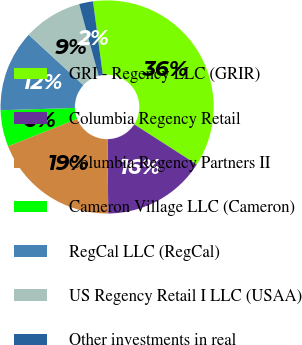Convert chart. <chart><loc_0><loc_0><loc_500><loc_500><pie_chart><fcel>GRI - Regency LLC (GRIR)<fcel>Columbia Regency Retail<fcel>Columbia Regency Partners II<fcel>Cameron Village LLC (Cameron)<fcel>RegCal LLC (RegCal)<fcel>US Regency Retail I LLC (USAA)<fcel>Other investments in real<nl><fcel>36.2%<fcel>15.75%<fcel>19.16%<fcel>5.52%<fcel>12.34%<fcel>8.93%<fcel>2.11%<nl></chart> 